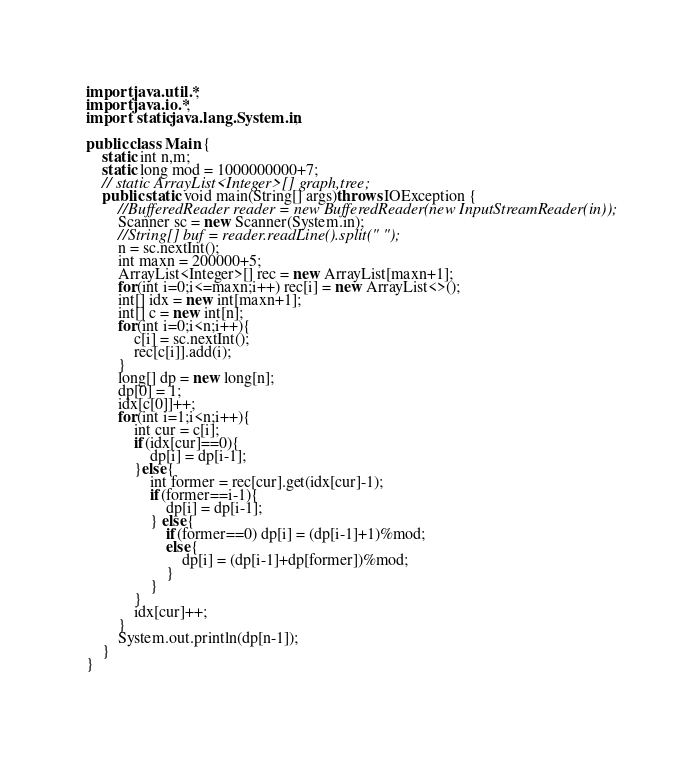<code> <loc_0><loc_0><loc_500><loc_500><_Java_>import java.util.*;
import java.io.*;
import static java.lang.System.in;

public class Main {
    static int n,m;
    static long mod = 1000000000+7;
    // static ArrayList<Integer>[] graph,tree;
    public static void main(String[] args)throws IOException {
        //BufferedReader reader = new BufferedReader(new InputStreamReader(in));
        Scanner sc = new Scanner(System.in);
        //String[] buf = reader.readLine().split(" ");
        n = sc.nextInt();
        int maxn = 200000+5;
        ArrayList<Integer>[] rec = new ArrayList[maxn+1];
        for(int i=0;i<=maxn;i++) rec[i] = new ArrayList<>();
        int[] idx = new int[maxn+1];
        int[] c = new int[n];
        for(int i=0;i<n;i++){
            c[i] = sc.nextInt();
            rec[c[i]].add(i);
        }
        long[] dp = new long[n];
        dp[0] = 1;
        idx[c[0]]++;
        for(int i=1;i<n;i++){
            int cur = c[i];
            if(idx[cur]==0){
                dp[i] = dp[i-1];
            }else{
                int former = rec[cur].get(idx[cur]-1);
                if(former==i-1){
                    dp[i] = dp[i-1];
                } else{
                    if(former==0) dp[i] = (dp[i-1]+1)%mod;
                    else{
                        dp[i] = (dp[i-1]+dp[former])%mod;
                    }
                }
            }
            idx[cur]++;
        }
        System.out.println(dp[n-1]);
    }
}</code> 